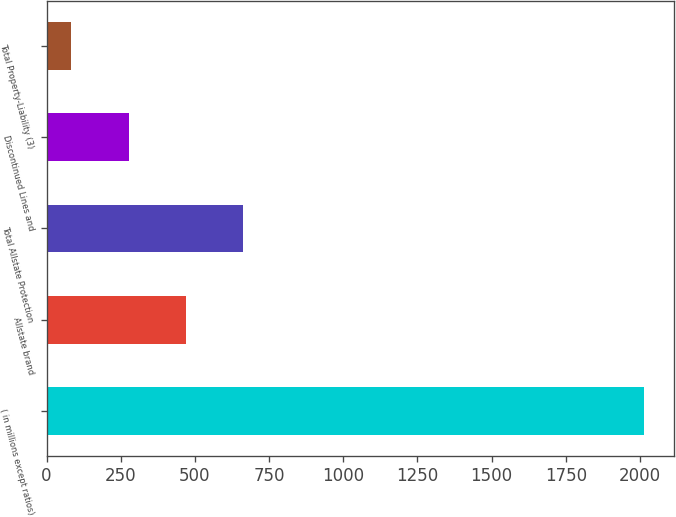<chart> <loc_0><loc_0><loc_500><loc_500><bar_chart><fcel>( in millions except ratios)<fcel>Allstate brand<fcel>Total Allstate Protection<fcel>Discontinued Lines and<fcel>Total Property-Liability (3)<nl><fcel>2014<fcel>470<fcel>663<fcel>277<fcel>84<nl></chart> 